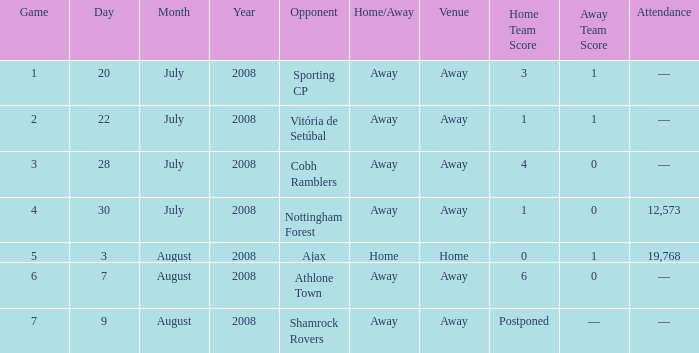What is the lowest game number on 20 July 2008? 1.0. 